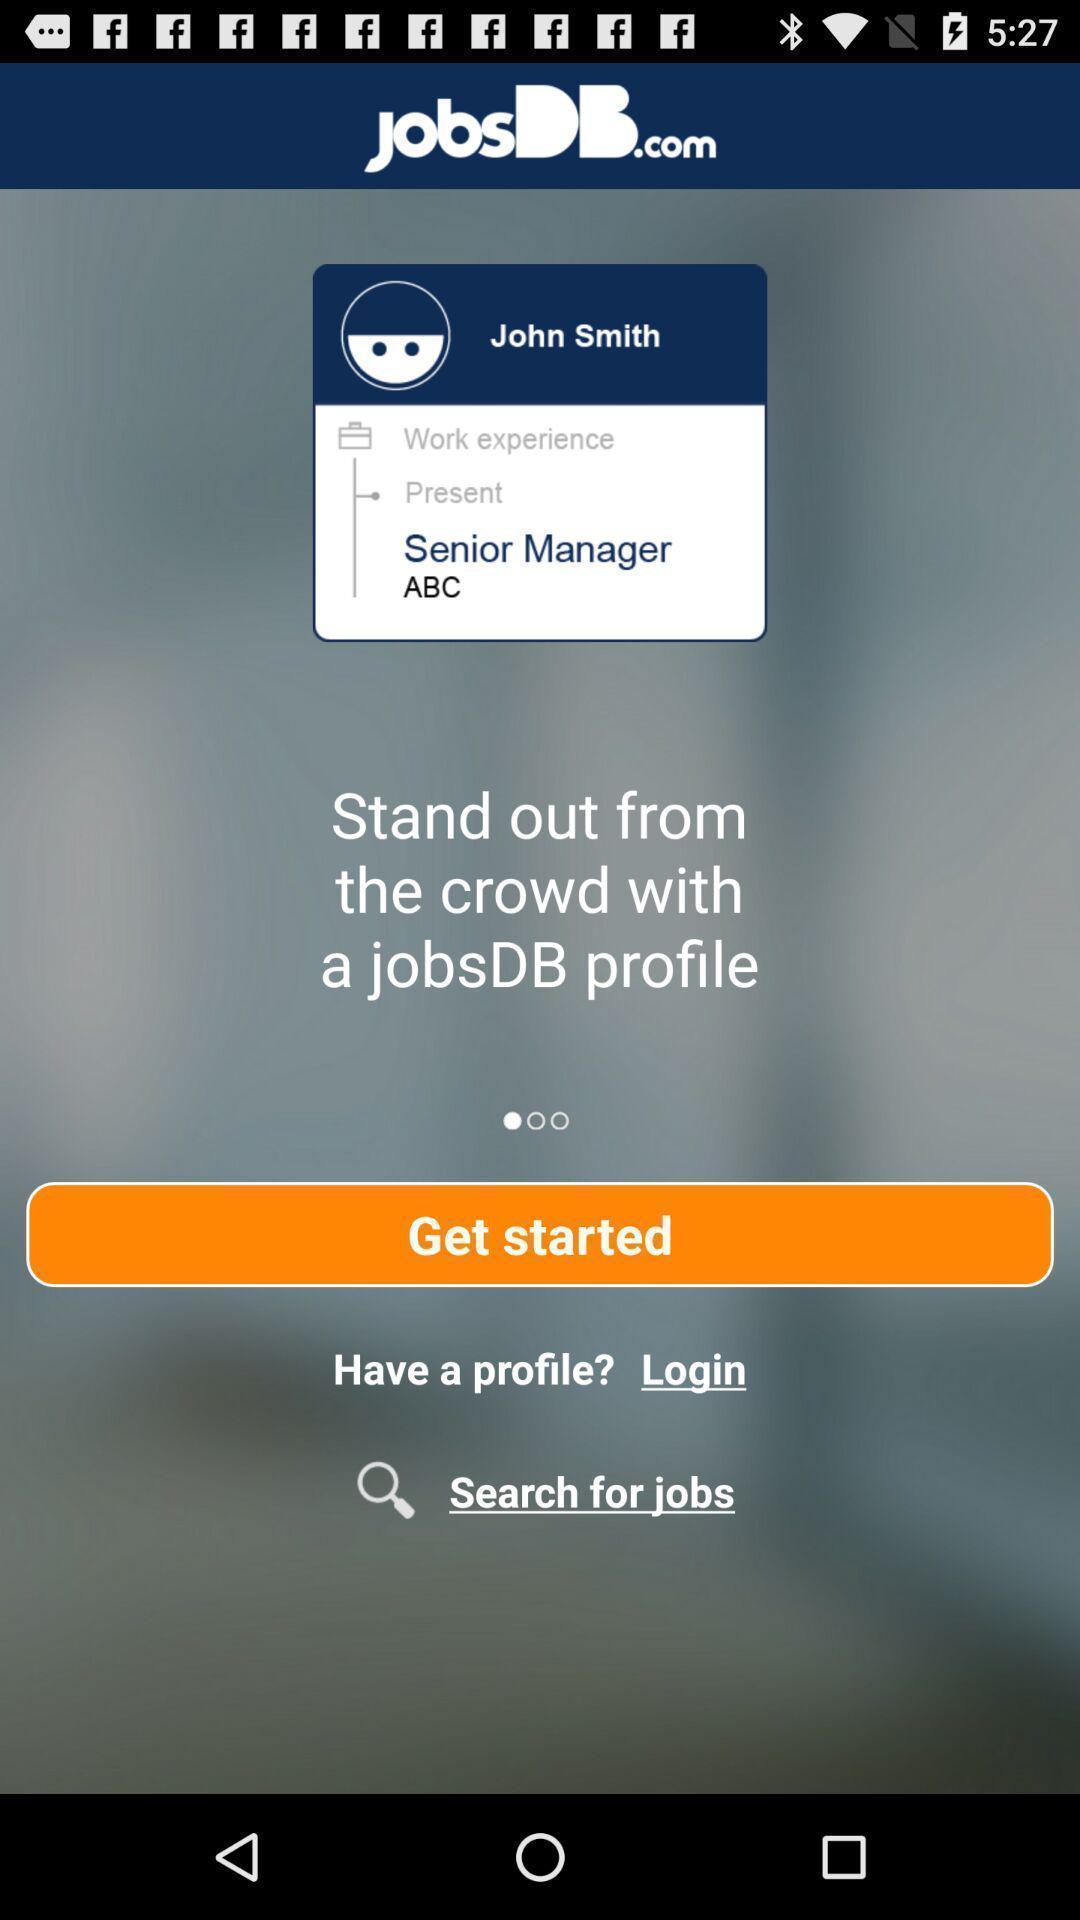Provide a detailed account of this screenshot. Welcome page of job searching app. 